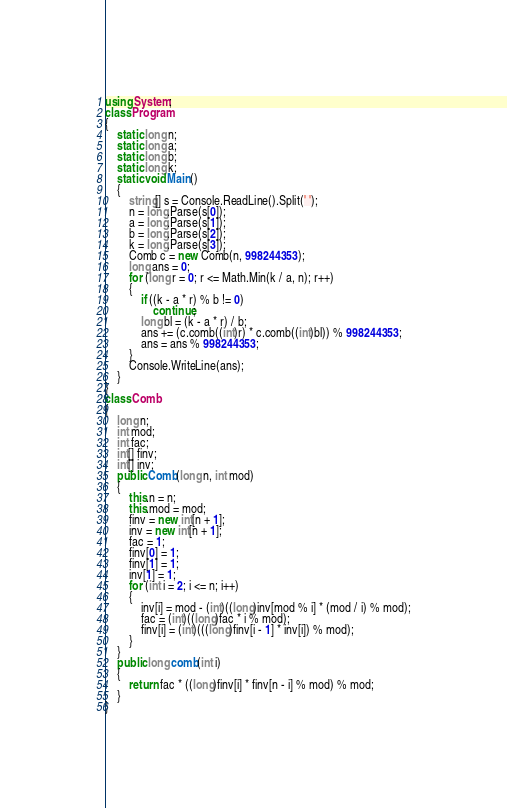Convert code to text. <code><loc_0><loc_0><loc_500><loc_500><_C#_>using System;
class Program
{
    static long n;
    static long a;
    static long b;
    static long k;
    static void Main()
    {
        string[] s = Console.ReadLine().Split(' ');
        n = long.Parse(s[0]);
        a = long.Parse(s[1]);
        b = long.Parse(s[2]);
        k = long.Parse(s[3]);
        Comb c = new Comb(n, 998244353);
        long ans = 0;
        for (long r = 0; r <= Math.Min(k / a, n); r++)
        {
            if ((k - a * r) % b != 0)
                continue;
            long bl = (k - a * r) / b;
            ans += (c.comb((int)r) * c.comb((int)bl)) % 998244353;
            ans = ans % 998244353;
        }
        Console.WriteLine(ans);
    }
}
class Comb
{
    long n;
    int mod;
    int fac;
    int[] finv;
    int[] inv;
    public Comb(long n, int mod)
    {
        this.n = n;
        this.mod = mod;
        finv = new int[n + 1];
        inv = new int[n + 1];
        fac = 1;
        finv[0] = 1;
        finv[1] = 1;
        inv[1] = 1;
        for (int i = 2; i <= n; i++)
        {
            inv[i] = mod - (int)((long)inv[mod % i] * (mod / i) % mod);
            fac = (int)((long)fac * i % mod);
            finv[i] = (int)(((long)finv[i - 1] * inv[i]) % mod);
        }
    }
    public long comb(int i)
    {
        return fac * ((long)finv[i] * finv[n - i] % mod) % mod;
    }
}</code> 